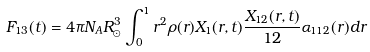Convert formula to latex. <formula><loc_0><loc_0><loc_500><loc_500>F _ { 1 3 } ( t ) = 4 \pi N _ { A } R _ { \odot } ^ { 3 } \int _ { 0 } ^ { 1 } r ^ { 2 } \rho ( r ) X _ { 1 } ( r , t ) \frac { X _ { 1 2 } ( r , t ) } { 1 2 } \alpha _ { 1 1 2 } ( r ) d r</formula> 